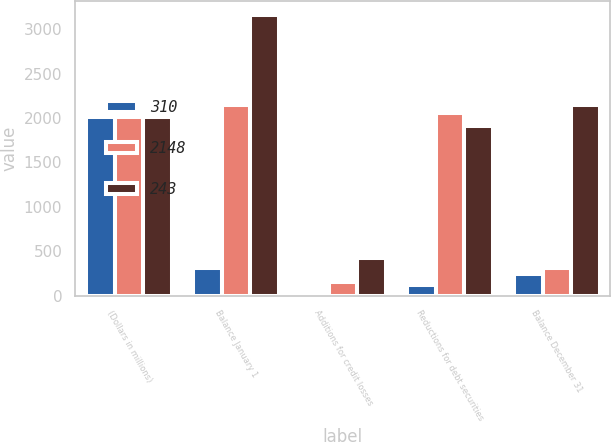Convert chart to OTSL. <chart><loc_0><loc_0><loc_500><loc_500><stacked_bar_chart><ecel><fcel>(Dollars in millions)<fcel>Balance January 1<fcel>Additions for credit losses<fcel>Reductions for debt securities<fcel>Balance December 31<nl><fcel>310<fcel>2012<fcel>310<fcel>46<fcel>120<fcel>243<nl><fcel>2148<fcel>2011<fcel>2148<fcel>149<fcel>2059<fcel>310<nl><fcel>243<fcel>2010<fcel>3155<fcel>421<fcel>1915<fcel>2148<nl></chart> 